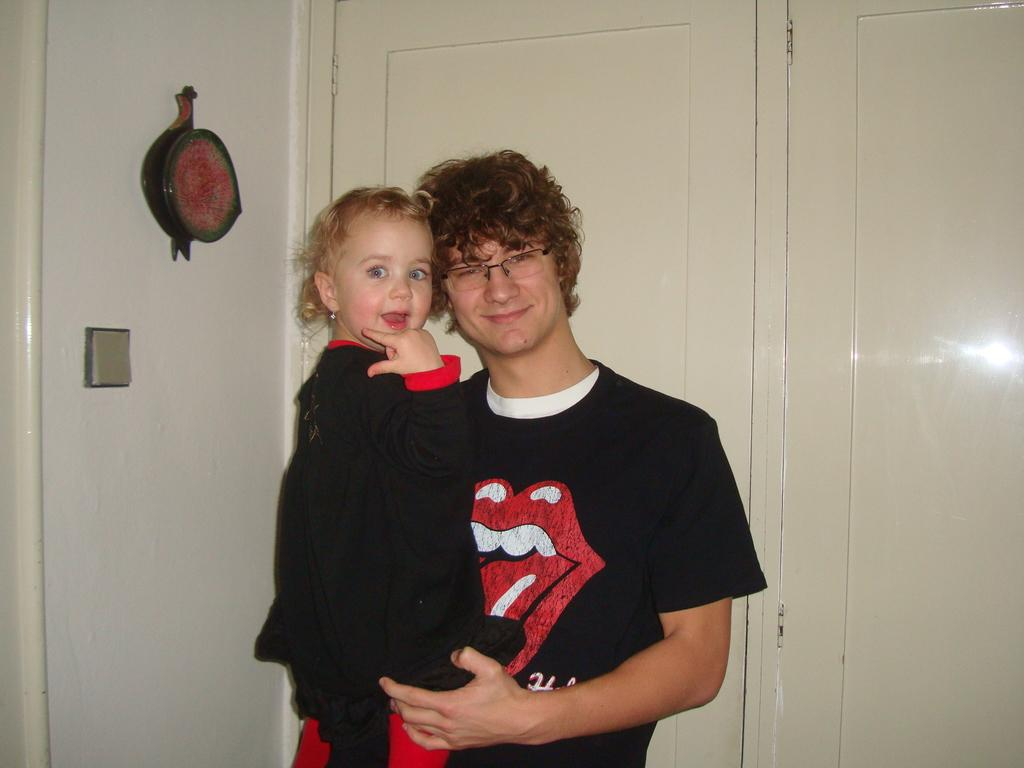Who is present in the image? There is a man in the image. What is the man doing in the image? The man is smiling in the image. What is the man wearing in the image? The man is wearing a black color T-shirt in the image. What is the man holding in the image? The man is carrying a baby girl in the image. What can be seen in the background of the image? There is a door visible in the background of the image. What type of flame can be seen coming from the man's T-shirt in the image? There is no flame present in the image; the man is wearing a black color T-shirt. What kind of worm is crawling on the baby girl's face in the image? There is no worm present in the image; the man is carrying a baby girl. 